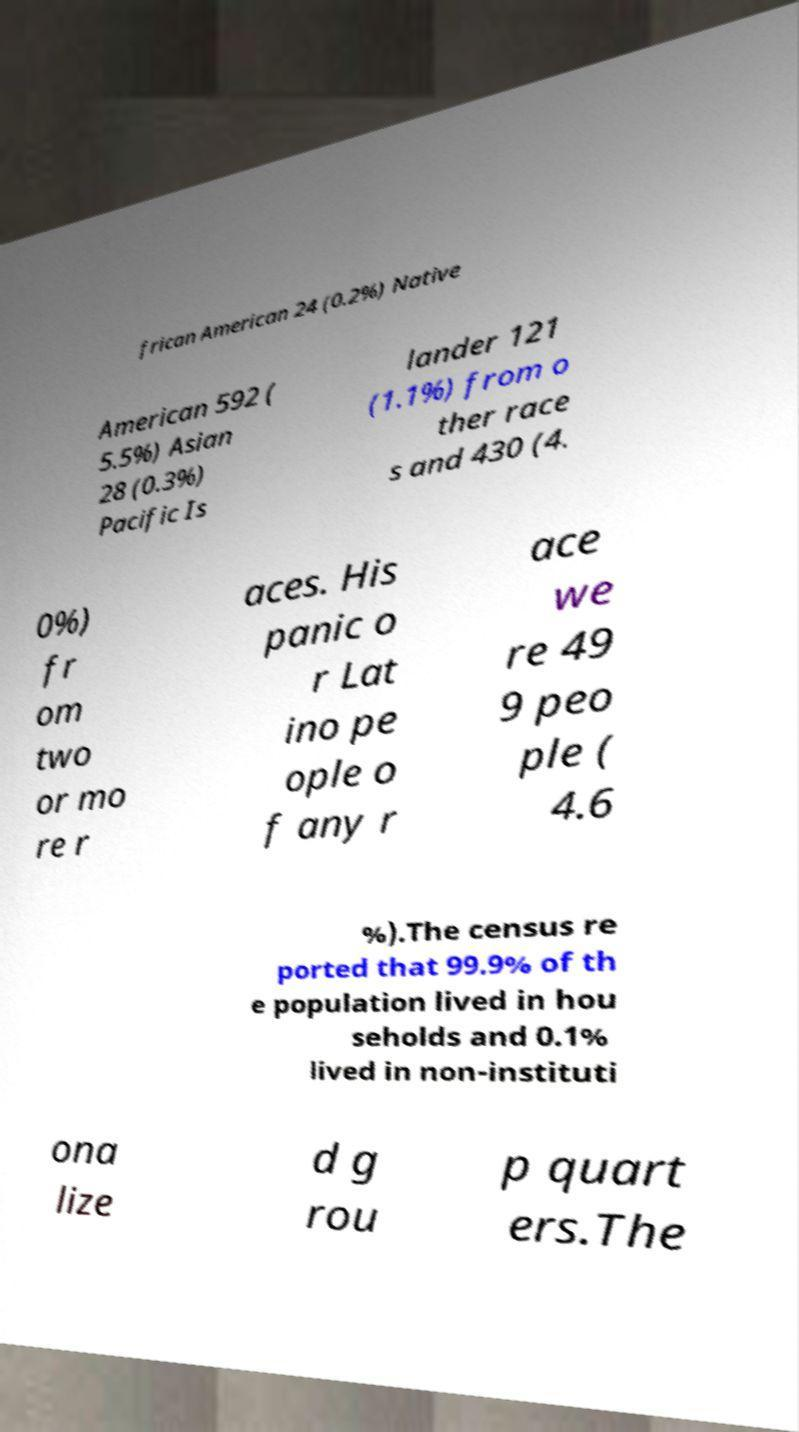What messages or text are displayed in this image? I need them in a readable, typed format. frican American 24 (0.2%) Native American 592 ( 5.5%) Asian 28 (0.3%) Pacific Is lander 121 (1.1%) from o ther race s and 430 (4. 0%) fr om two or mo re r aces. His panic o r Lat ino pe ople o f any r ace we re 49 9 peo ple ( 4.6 %).The census re ported that 99.9% of th e population lived in hou seholds and 0.1% lived in non-instituti ona lize d g rou p quart ers.The 